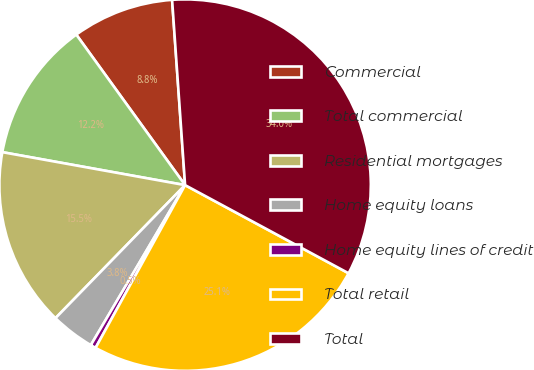<chart> <loc_0><loc_0><loc_500><loc_500><pie_chart><fcel>Commercial<fcel>Total commercial<fcel>Residential mortgages<fcel>Home equity loans<fcel>Home equity lines of credit<fcel>Total retail<fcel>Total<nl><fcel>8.85%<fcel>12.2%<fcel>15.55%<fcel>3.82%<fcel>0.47%<fcel>25.14%<fcel>33.99%<nl></chart> 